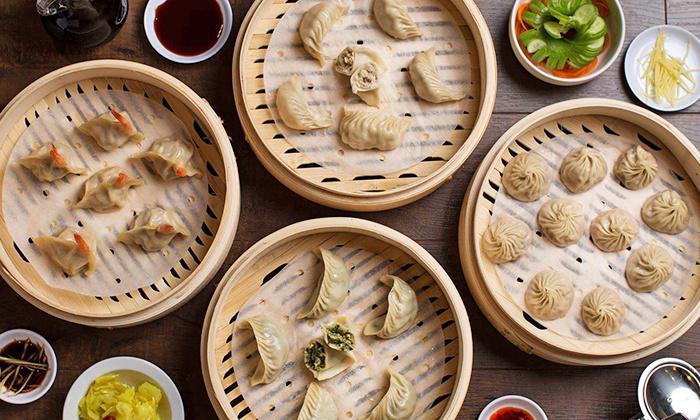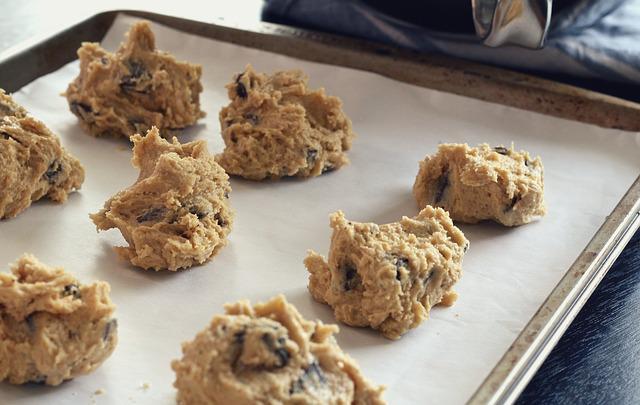The first image is the image on the left, the second image is the image on the right. Considering the images on both sides, is "There are multiple raw cookies on a baking sheet." valid? Answer yes or no. Yes. The first image is the image on the left, the second image is the image on the right. Assess this claim about the two images: "The right image features mounds of raw cookie dough in rows with a metal sheet under them.". Correct or not? Answer yes or no. Yes. 